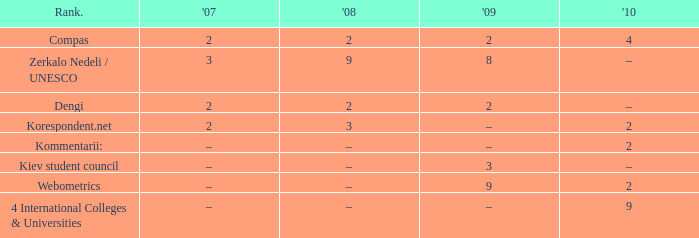What was the 2009 ranking for Webometrics? 9.0. 